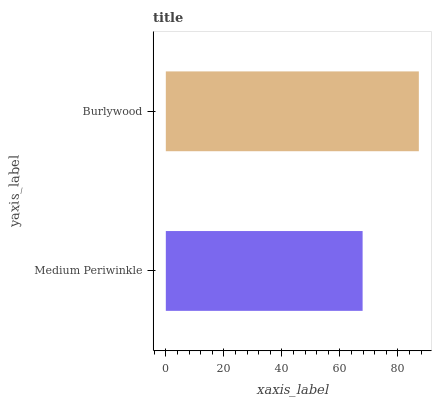Is Medium Periwinkle the minimum?
Answer yes or no. Yes. Is Burlywood the maximum?
Answer yes or no. Yes. Is Burlywood the minimum?
Answer yes or no. No. Is Burlywood greater than Medium Periwinkle?
Answer yes or no. Yes. Is Medium Periwinkle less than Burlywood?
Answer yes or no. Yes. Is Medium Periwinkle greater than Burlywood?
Answer yes or no. No. Is Burlywood less than Medium Periwinkle?
Answer yes or no. No. Is Burlywood the high median?
Answer yes or no. Yes. Is Medium Periwinkle the low median?
Answer yes or no. Yes. Is Medium Periwinkle the high median?
Answer yes or no. No. Is Burlywood the low median?
Answer yes or no. No. 